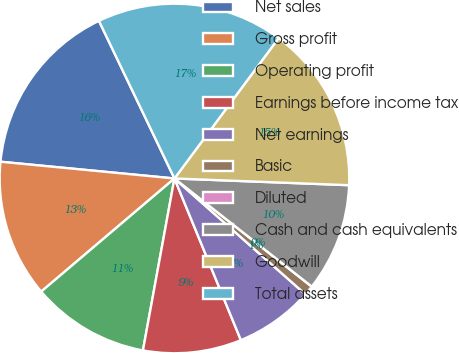Convert chart to OTSL. <chart><loc_0><loc_0><loc_500><loc_500><pie_chart><fcel>Net sales<fcel>Gross profit<fcel>Operating profit<fcel>Earnings before income tax<fcel>Net earnings<fcel>Basic<fcel>Diluted<fcel>Cash and cash equivalents<fcel>Goodwill<fcel>Total assets<nl><fcel>16.36%<fcel>12.73%<fcel>10.91%<fcel>9.09%<fcel>7.27%<fcel>0.91%<fcel>0.0%<fcel>10.0%<fcel>15.45%<fcel>17.27%<nl></chart> 